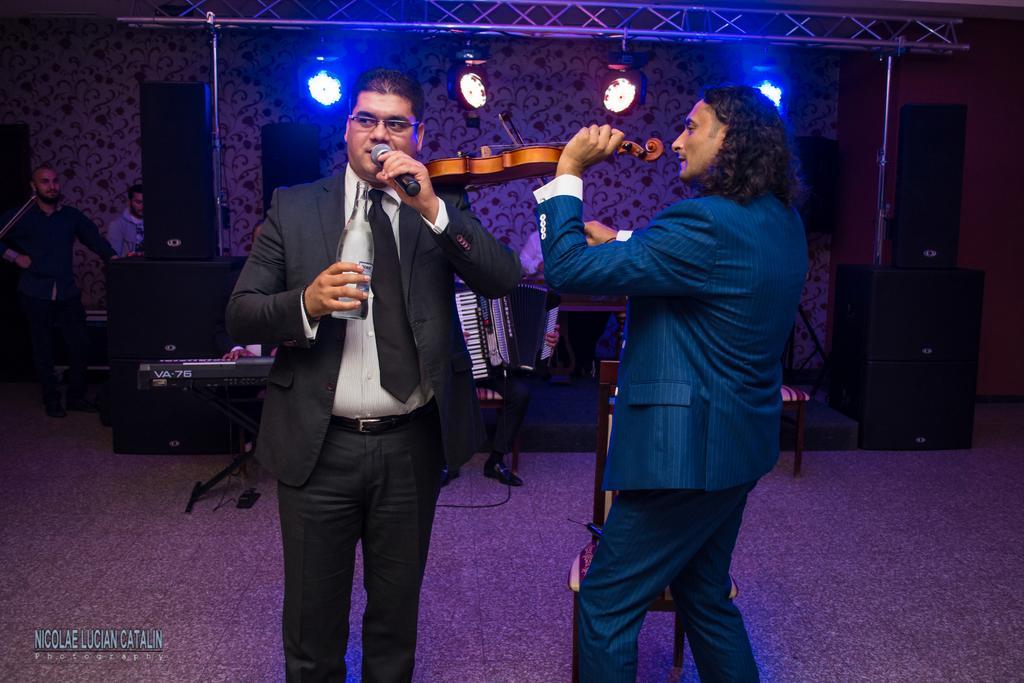Please provide a concise description of this image. In this image we can see few people standing on the floor and some of them are playing musical instruments, a person is holding a mic and a bottle, there are few objects looks like speakers, there are few lights to the iron pole. 